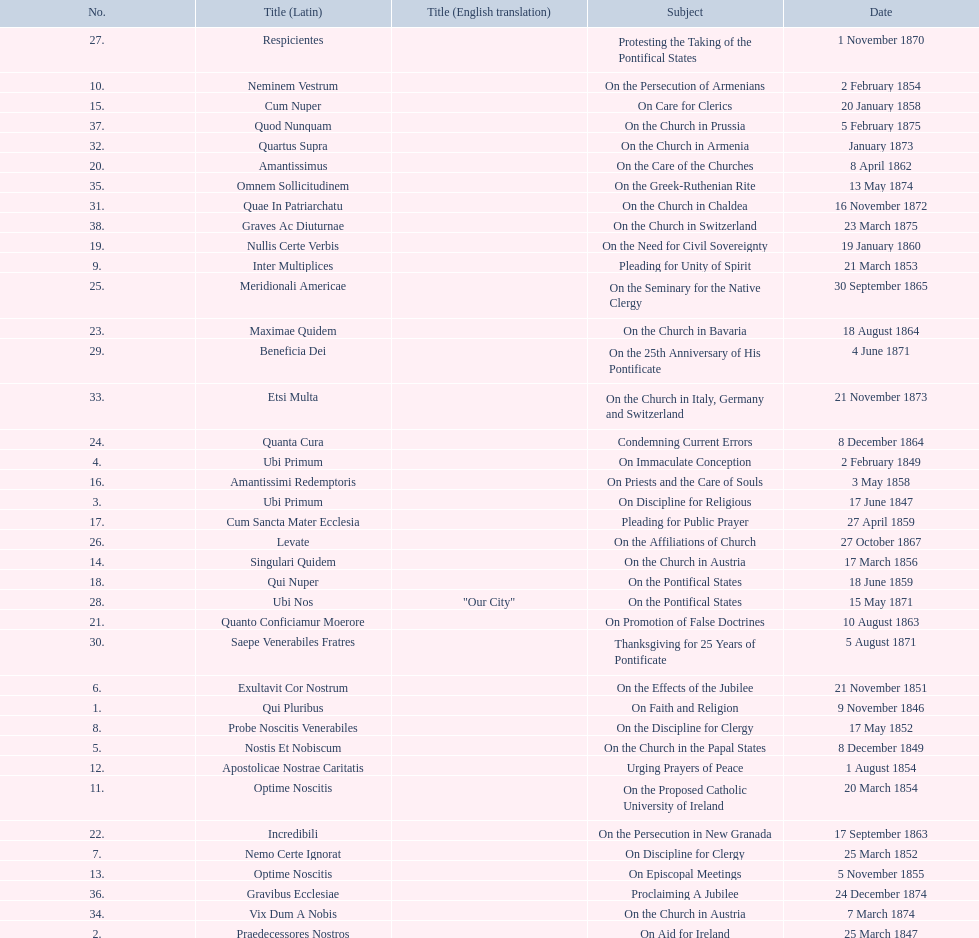What is the overall count of titles? 38. 